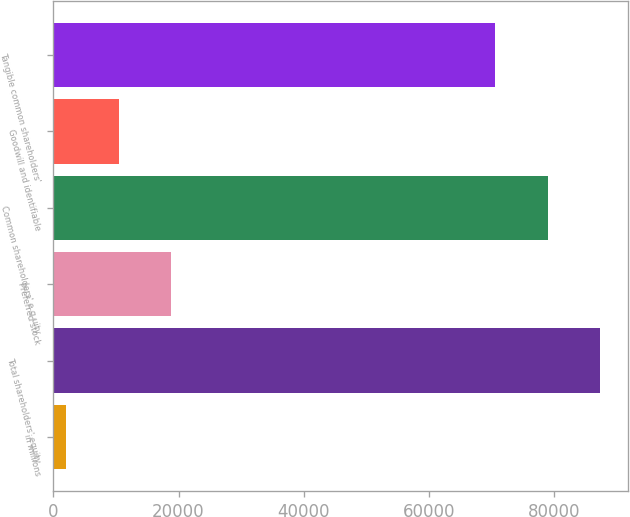Convert chart to OTSL. <chart><loc_0><loc_0><loc_500><loc_500><bar_chart><fcel>in millions<fcel>Total shareholders' equity<fcel>Preferred stock<fcel>Common shareholders' e q uity<fcel>Goodwill and identifiable<fcel>Tangible common shareholders'<nl><fcel>2017<fcel>87444.4<fcel>18805.4<fcel>79050.2<fcel>10411.2<fcel>70656<nl></chart> 